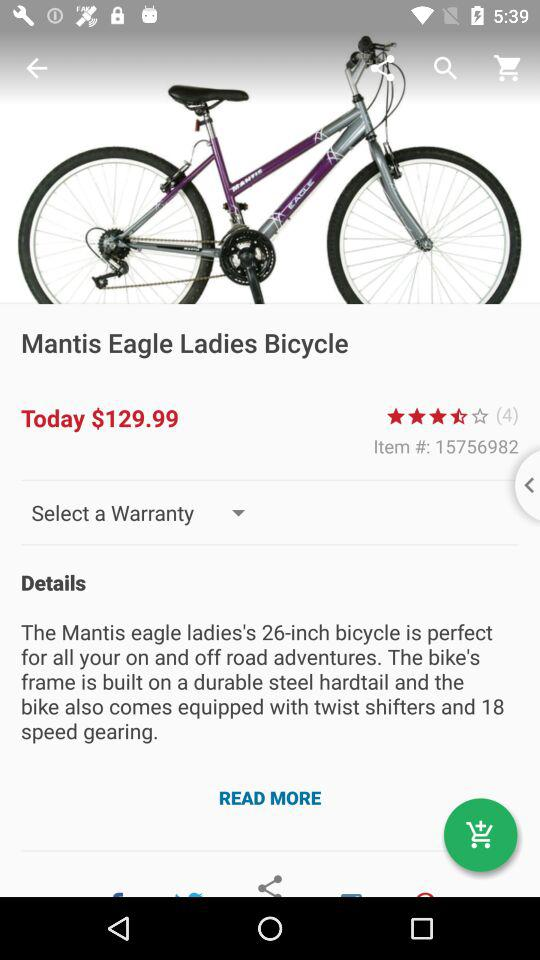What is the price of bicycle? The price is $129.99. 